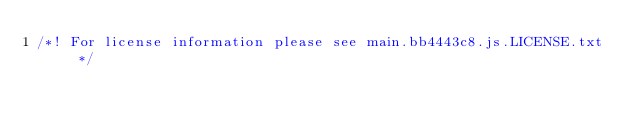<code> <loc_0><loc_0><loc_500><loc_500><_JavaScript_>/*! For license information please see main.bb4443c8.js.LICENSE.txt */</code> 